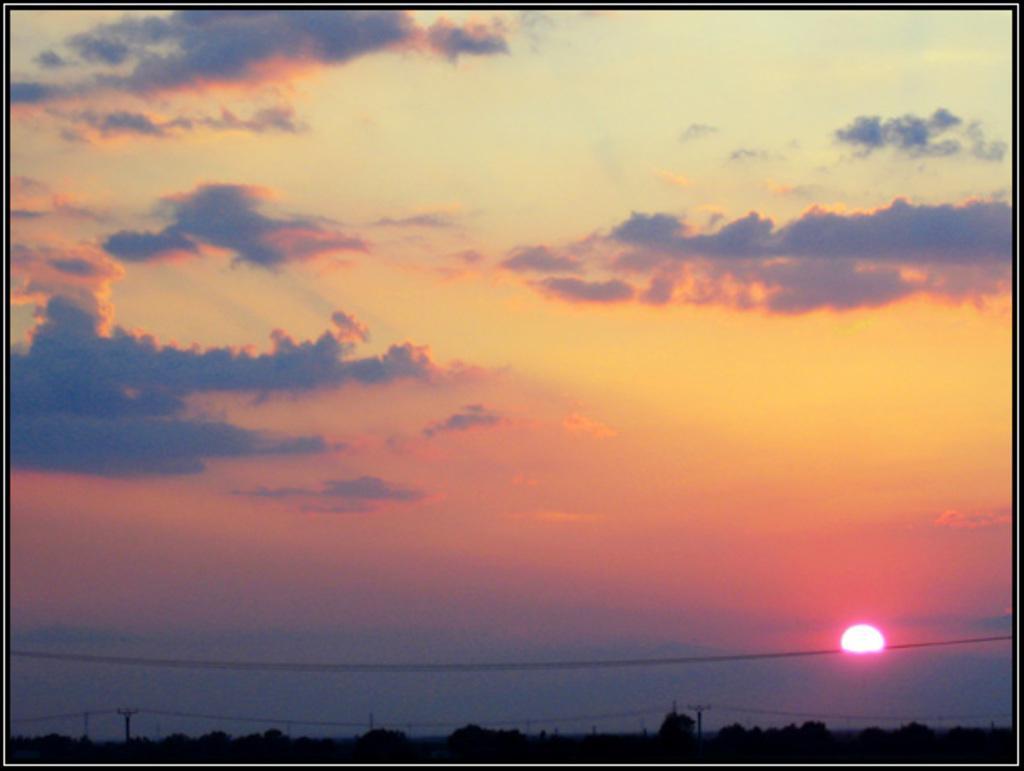How would you summarize this image in a sentence or two? In this image I see the sky, sun, wires and poles and I see that it is a bit dark over here. 